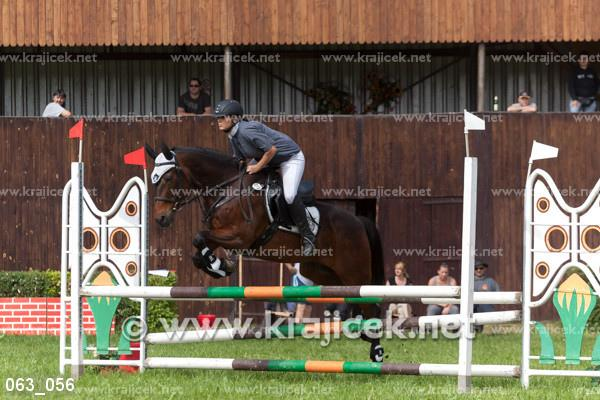Which bar is the horse meant to pass over? Please explain your reasoning. top bar. A horse is jumping over a bar in an obstacle course with a jockey riding on it. the bars are set up, one directly over the other. 